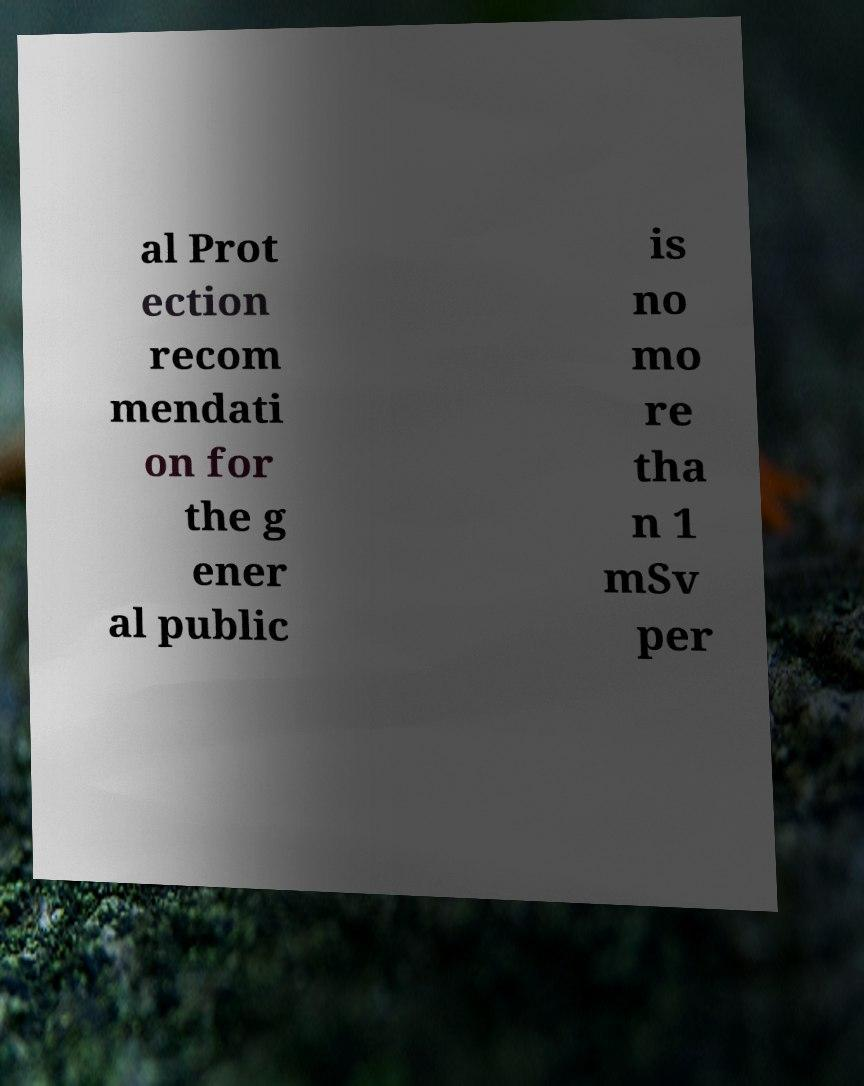There's text embedded in this image that I need extracted. Can you transcribe it verbatim? al Prot ection recom mendati on for the g ener al public is no mo re tha n 1 mSv per 